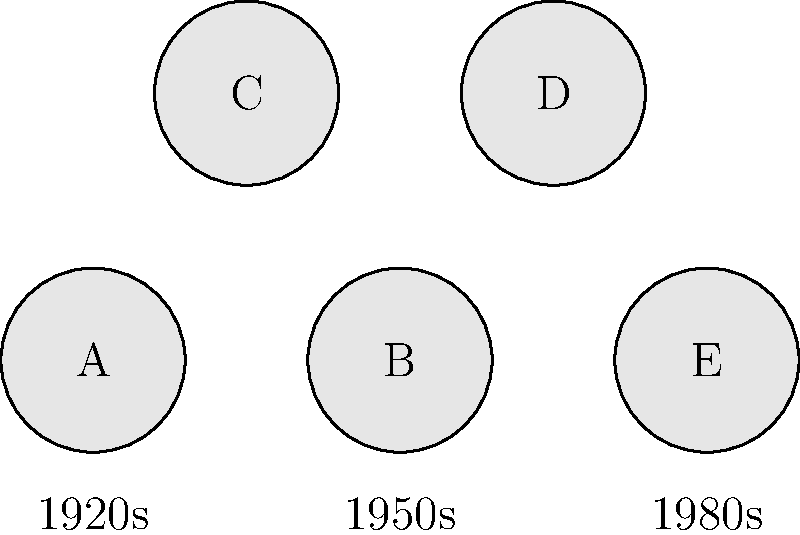Based on your extensive research of hotel history, which of the labeled objects (A, B, C, D, or E) most likely represents a rotary telephone, commonly found in upscale hotels of the mid-20th century? To answer this question, we need to consider the historical context of hotel furnishings:

1. Object A is associated with the 1920s, which is too early for widespread use of rotary telephones in hotels.

2. Object B is positioned under the 1950s label. This aligns perfectly with the golden age of rotary telephones in hotels.

3. Objects C and D are not directly associated with a specific time period in the diagram.

4. Object E is linked to the 1980s, which is generally too late for rotary phones as push-button phones became more common.

5. Rotary telephones were most prevalent in hotels from the 1930s to the 1960s, with the 1950s being the peak of their popularity.

6. Upscale hotels of the mid-20th century (1940s-1960s) would have certainly featured rotary telephones as a modern amenity.

Given this information, the object most likely to represent a rotary telephone in an upscale mid-20th century hotel is Object B, corresponding to the 1950s era.
Answer: B 